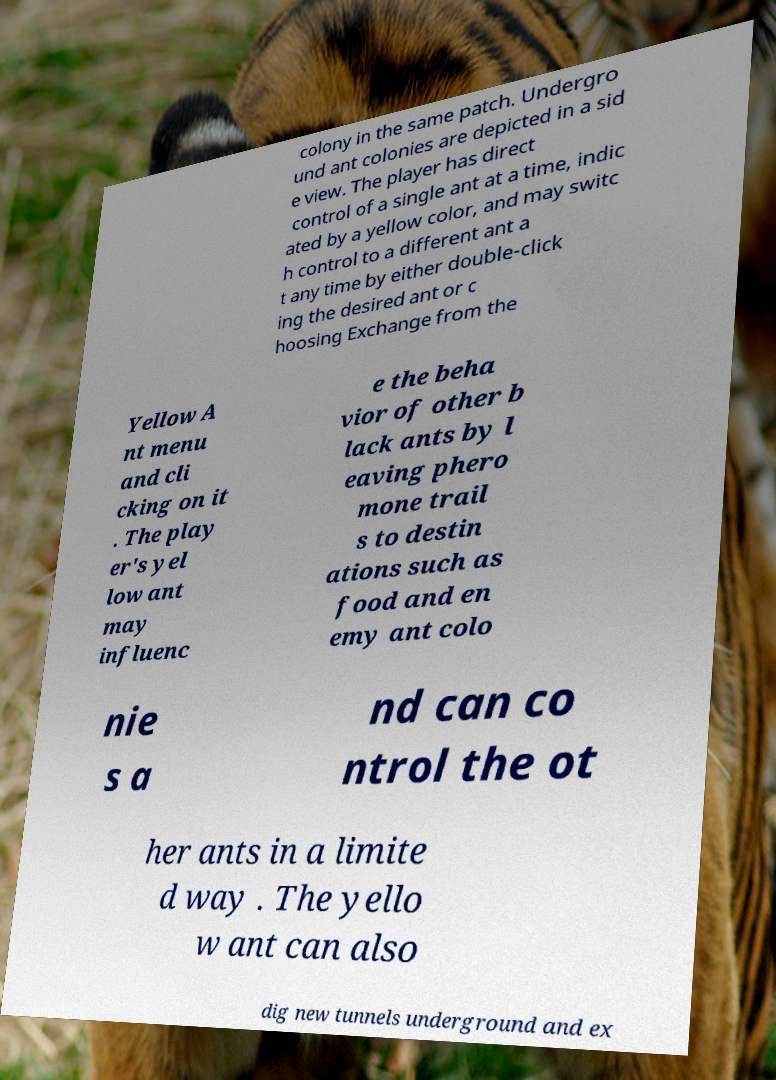Could you assist in decoding the text presented in this image and type it out clearly? colony in the same patch. Undergro und ant colonies are depicted in a sid e view. The player has direct control of a single ant at a time, indic ated by a yellow color, and may switc h control to a different ant a t any time by either double-click ing the desired ant or c hoosing Exchange from the Yellow A nt menu and cli cking on it . The play er's yel low ant may influenc e the beha vior of other b lack ants by l eaving phero mone trail s to destin ations such as food and en emy ant colo nie s a nd can co ntrol the ot her ants in a limite d way . The yello w ant can also dig new tunnels underground and ex 